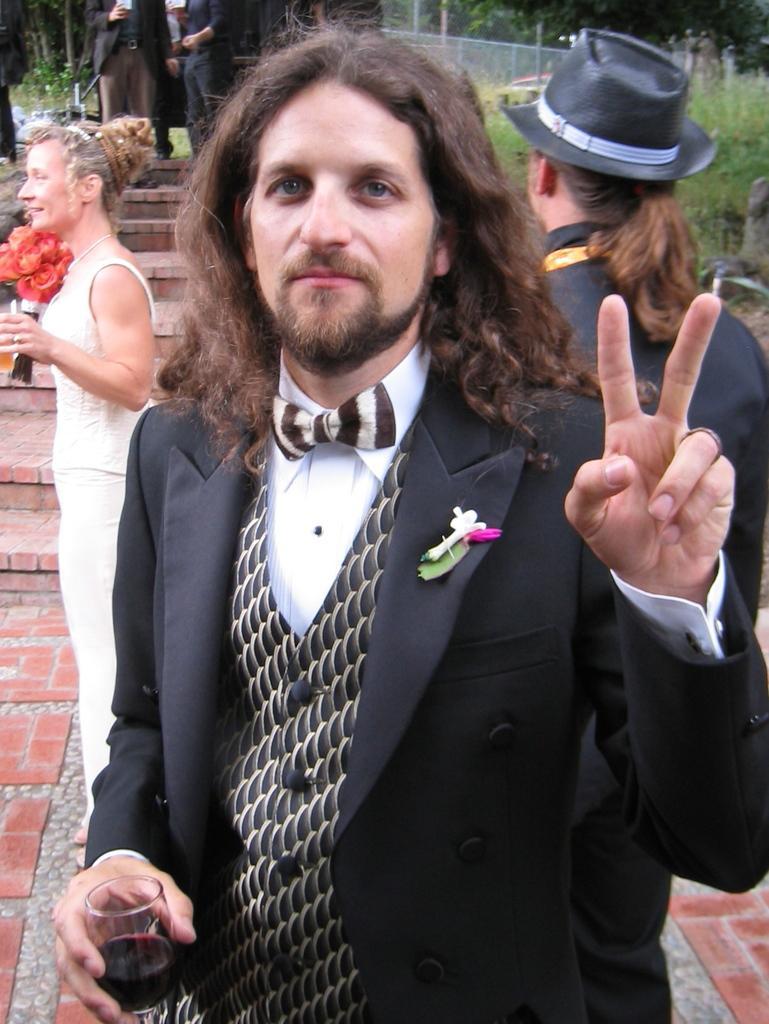How would you summarize this image in a sentence or two? In this image there are people. The person standing on the left is holding a flower bouquet. In the background there are trees and we can see a fence. There are stairs. 